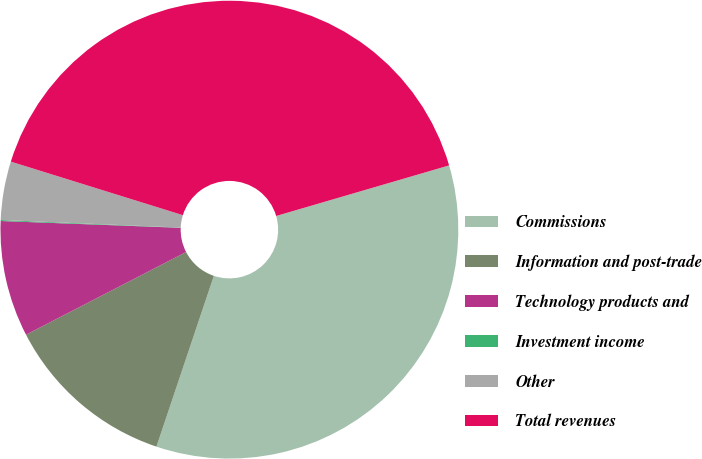Convert chart. <chart><loc_0><loc_0><loc_500><loc_500><pie_chart><fcel>Commissions<fcel>Information and post-trade<fcel>Technology products and<fcel>Investment income<fcel>Other<fcel>Total revenues<nl><fcel>34.69%<fcel>12.25%<fcel>8.19%<fcel>0.07%<fcel>4.13%<fcel>40.67%<nl></chart> 